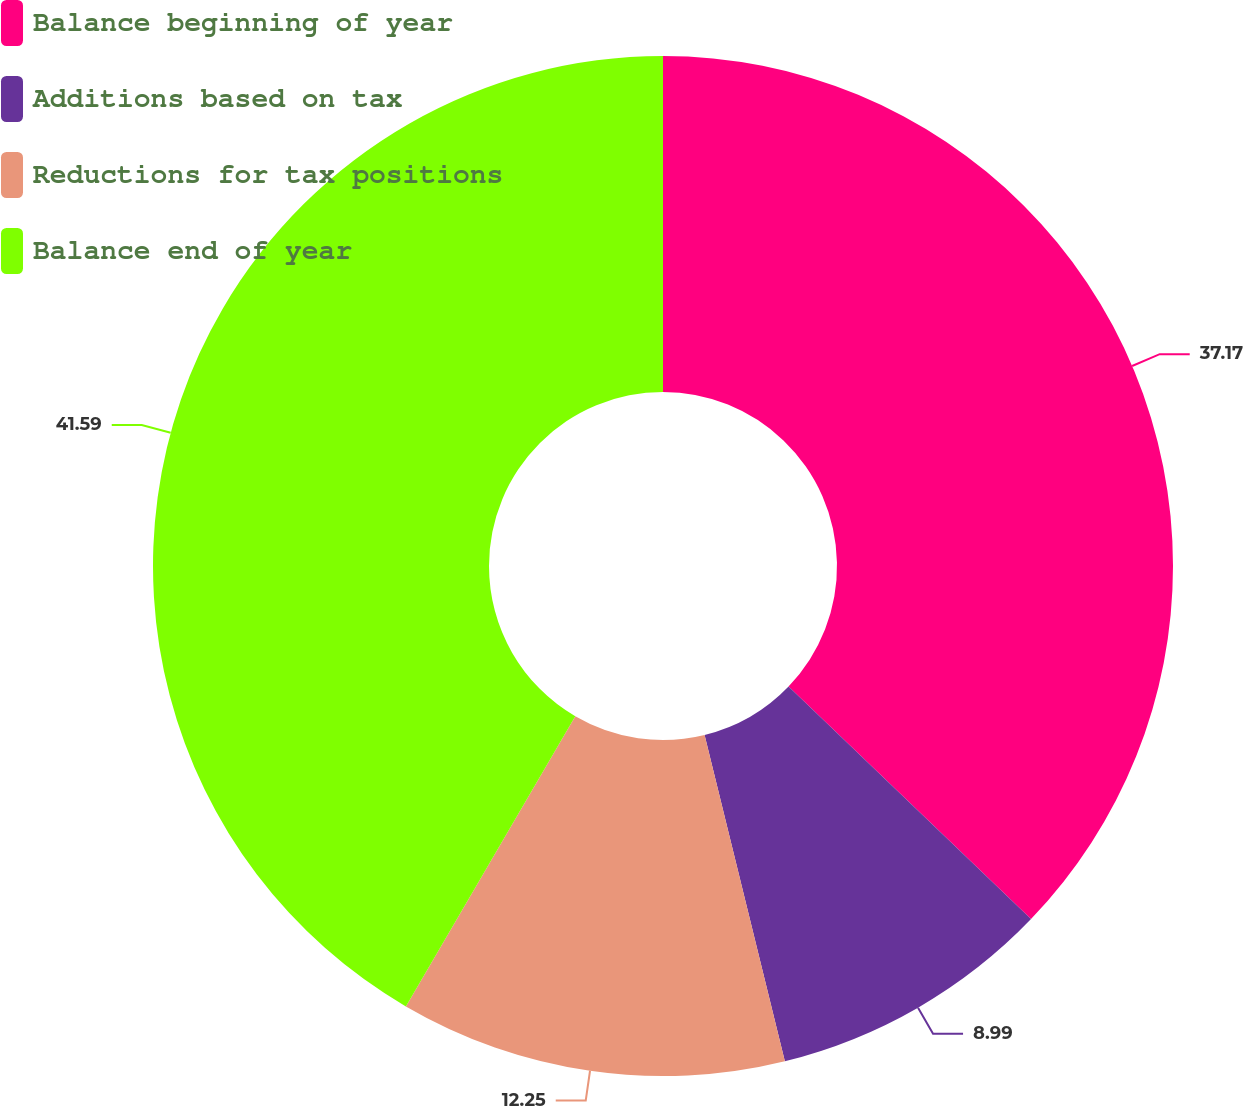<chart> <loc_0><loc_0><loc_500><loc_500><pie_chart><fcel>Balance beginning of year<fcel>Additions based on tax<fcel>Reductions for tax positions<fcel>Balance end of year<nl><fcel>37.17%<fcel>8.99%<fcel>12.25%<fcel>41.59%<nl></chart> 